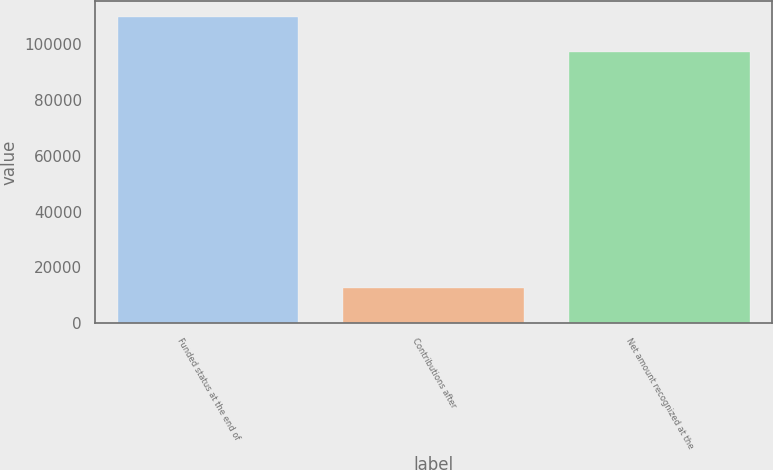<chart> <loc_0><loc_0><loc_500><loc_500><bar_chart><fcel>Funded status at the end of<fcel>Contributions after<fcel>Net amount recognized at the<nl><fcel>109841<fcel>12561<fcel>97280<nl></chart> 